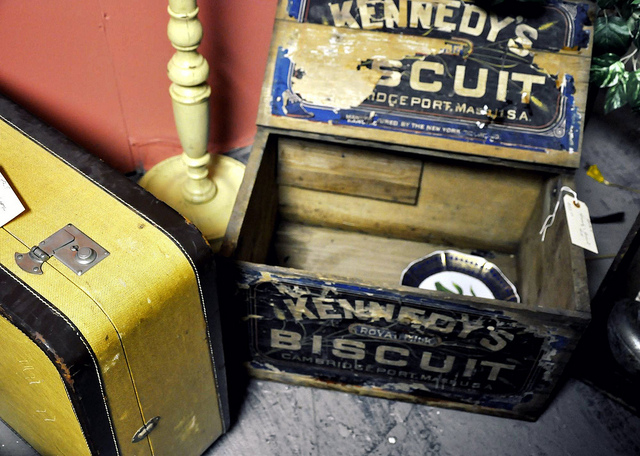Identify the text displayed in this image. SCUIT BISCUIT ROYAL 